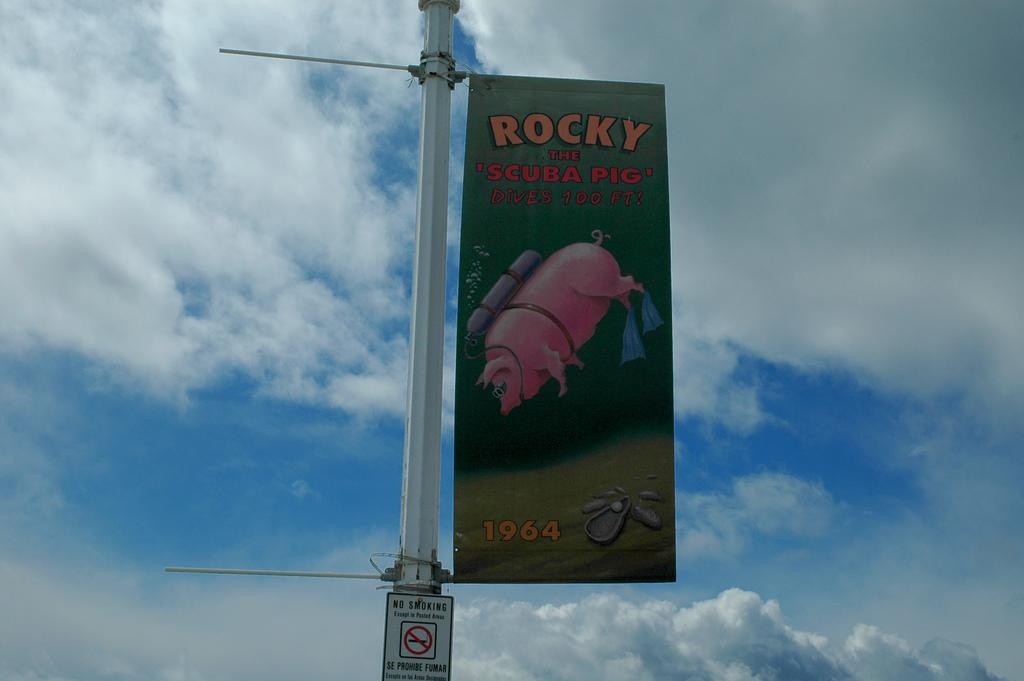<image>
Relay a brief, clear account of the picture shown. A flag for "Rocky the Scuba Pig" on a streetlamp 